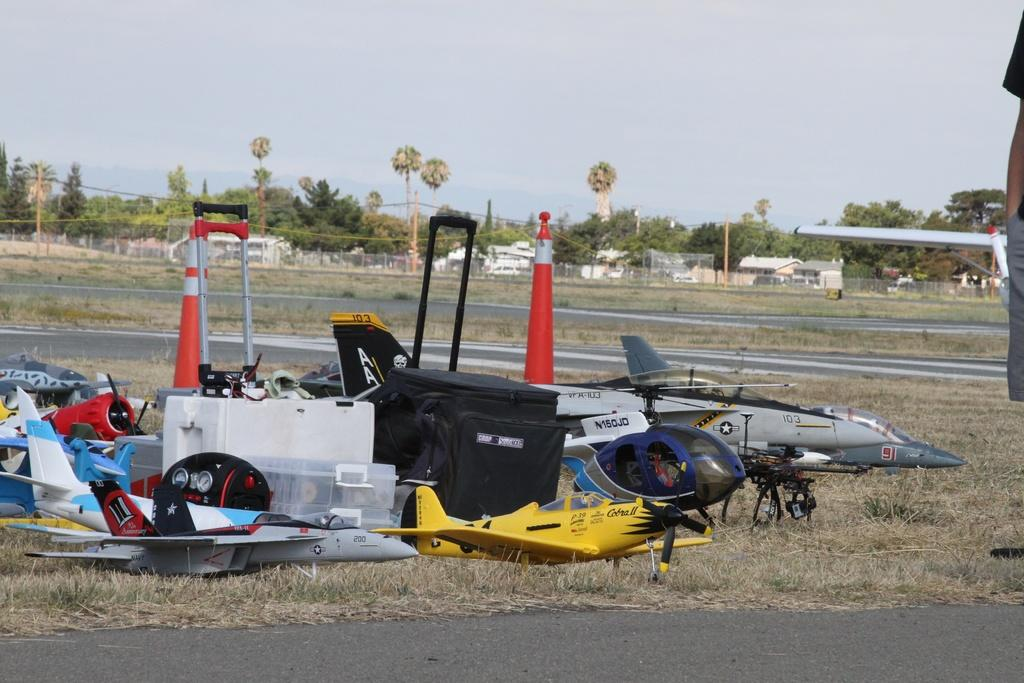<image>
Summarize the visual content of the image. A collection of toy RC airplanes are laid out on the grass including the yellow Cobra II in the front. 